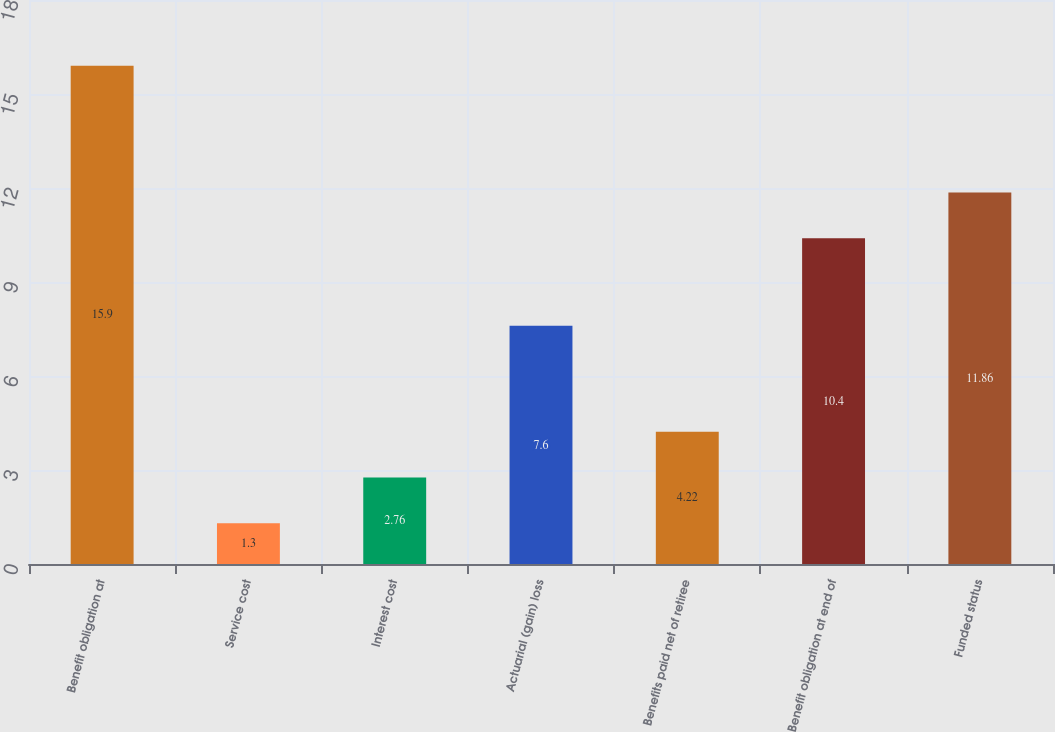Convert chart. <chart><loc_0><loc_0><loc_500><loc_500><bar_chart><fcel>Benefit obligation at<fcel>Service cost<fcel>Interest cost<fcel>Actuarial (gain) loss<fcel>Benefits paid net of retiree<fcel>Benefit obligation at end of<fcel>Funded status<nl><fcel>15.9<fcel>1.3<fcel>2.76<fcel>7.6<fcel>4.22<fcel>10.4<fcel>11.86<nl></chart> 